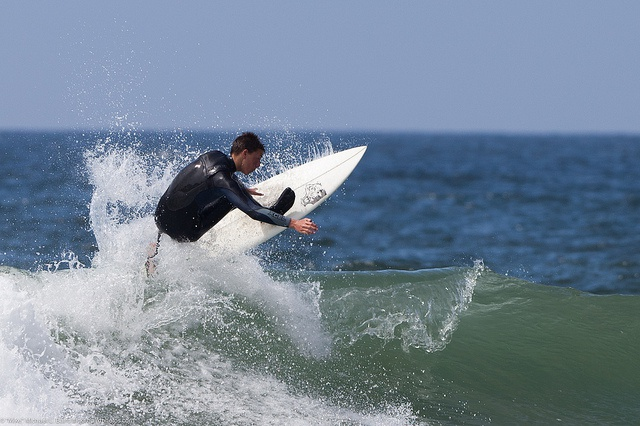Describe the objects in this image and their specific colors. I can see surfboard in darkgray, lightgray, and gray tones and people in darkgray, black, gray, and maroon tones in this image. 